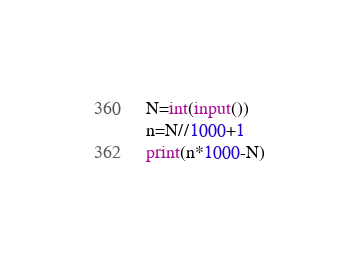Convert code to text. <code><loc_0><loc_0><loc_500><loc_500><_Python_>N=int(input())
n=N//1000+1
print(n*1000-N)</code> 